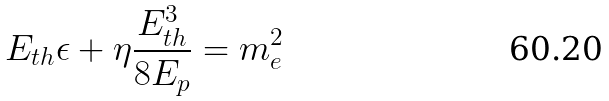Convert formula to latex. <formula><loc_0><loc_0><loc_500><loc_500>E _ { t h } \epsilon + \eta \frac { E _ { t h } ^ { 3 } } { 8 E _ { p } } = m _ { e } ^ { 2 }</formula> 